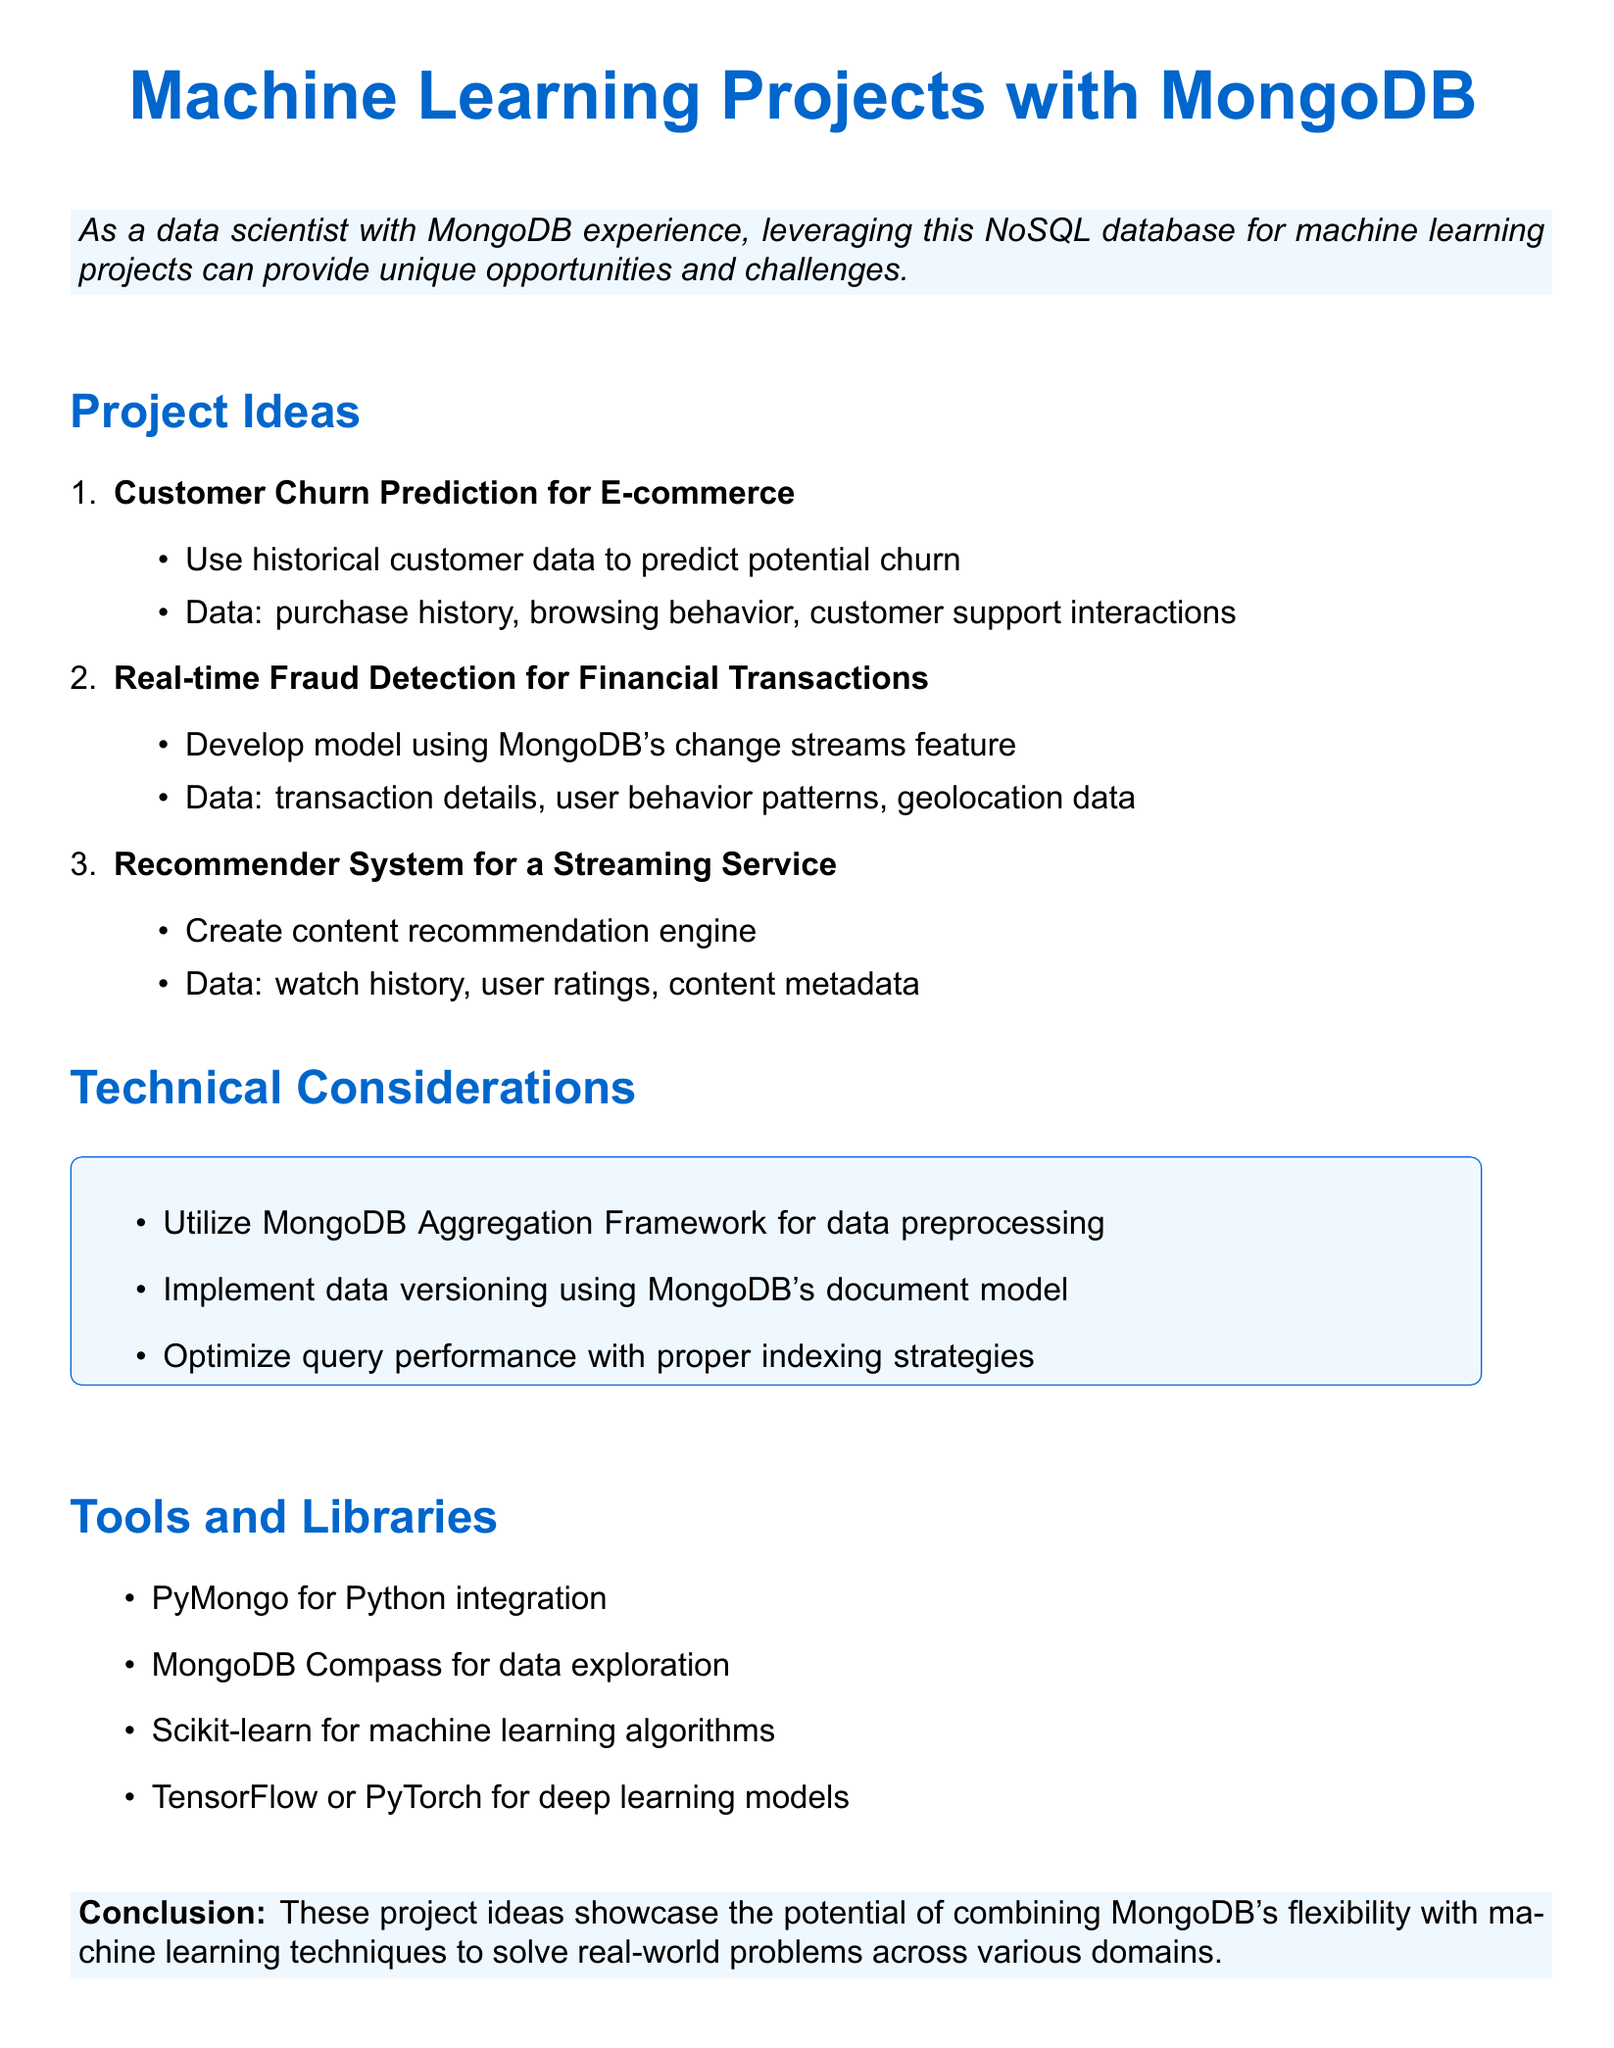what is the title of the document? The title is mentioned at the beginning of the document.
Answer: Ideas for Machine Learning Projects Using MongoDB as Data Source how many project ideas are listed? The number of project ideas is found in the project ideas section of the document.
Answer: 3 what is one of the data points for Customer Churn Prediction? The data points for this project are listed in the description section.
Answer: purchase history which tool is suggested for Python integration? The tools for the machine learning projects are listed in the tools and libraries section.
Answer: PyMongo what is the main purpose of the Real-time Fraud Detection project? The purpose is found in the project description section detailing its primary function.
Answer: detect fraudulent transactions which machine learning library is mentioned alongside TensorFlow? This information is included in the tools and libraries section.
Answer: PyTorch what technical consideration is emphasized for data preprocessing? The technical considerations listed address various aspects of implementing a project using MongoDB.
Answer: MongoDB Aggregation Framework what type of data is used for the Recommender System? The data used for this project can be extracted from the project ideas section.
Answer: watch history what is the conclusion about the combination of MongoDB and machine learning? The conclusion summarizes the overall findings and implications of the document.
Answer: solve real-world problems 